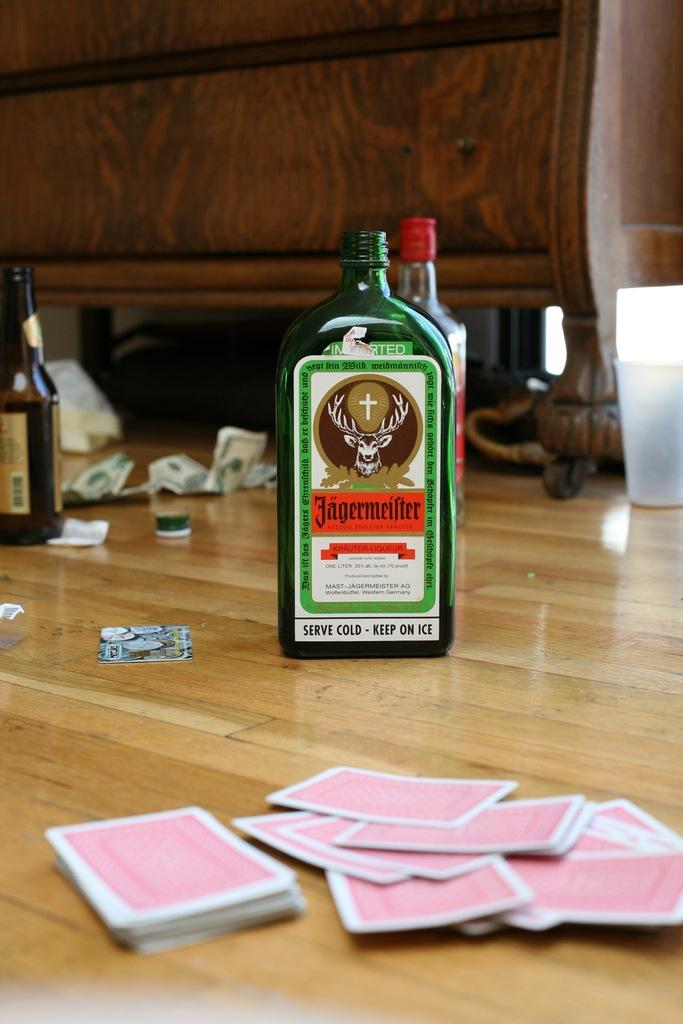<image>
Create a compact narrative representing the image presented. A variety of alcoholic beverages and a deck of cards, including a Jagermiester one liter bottle. 